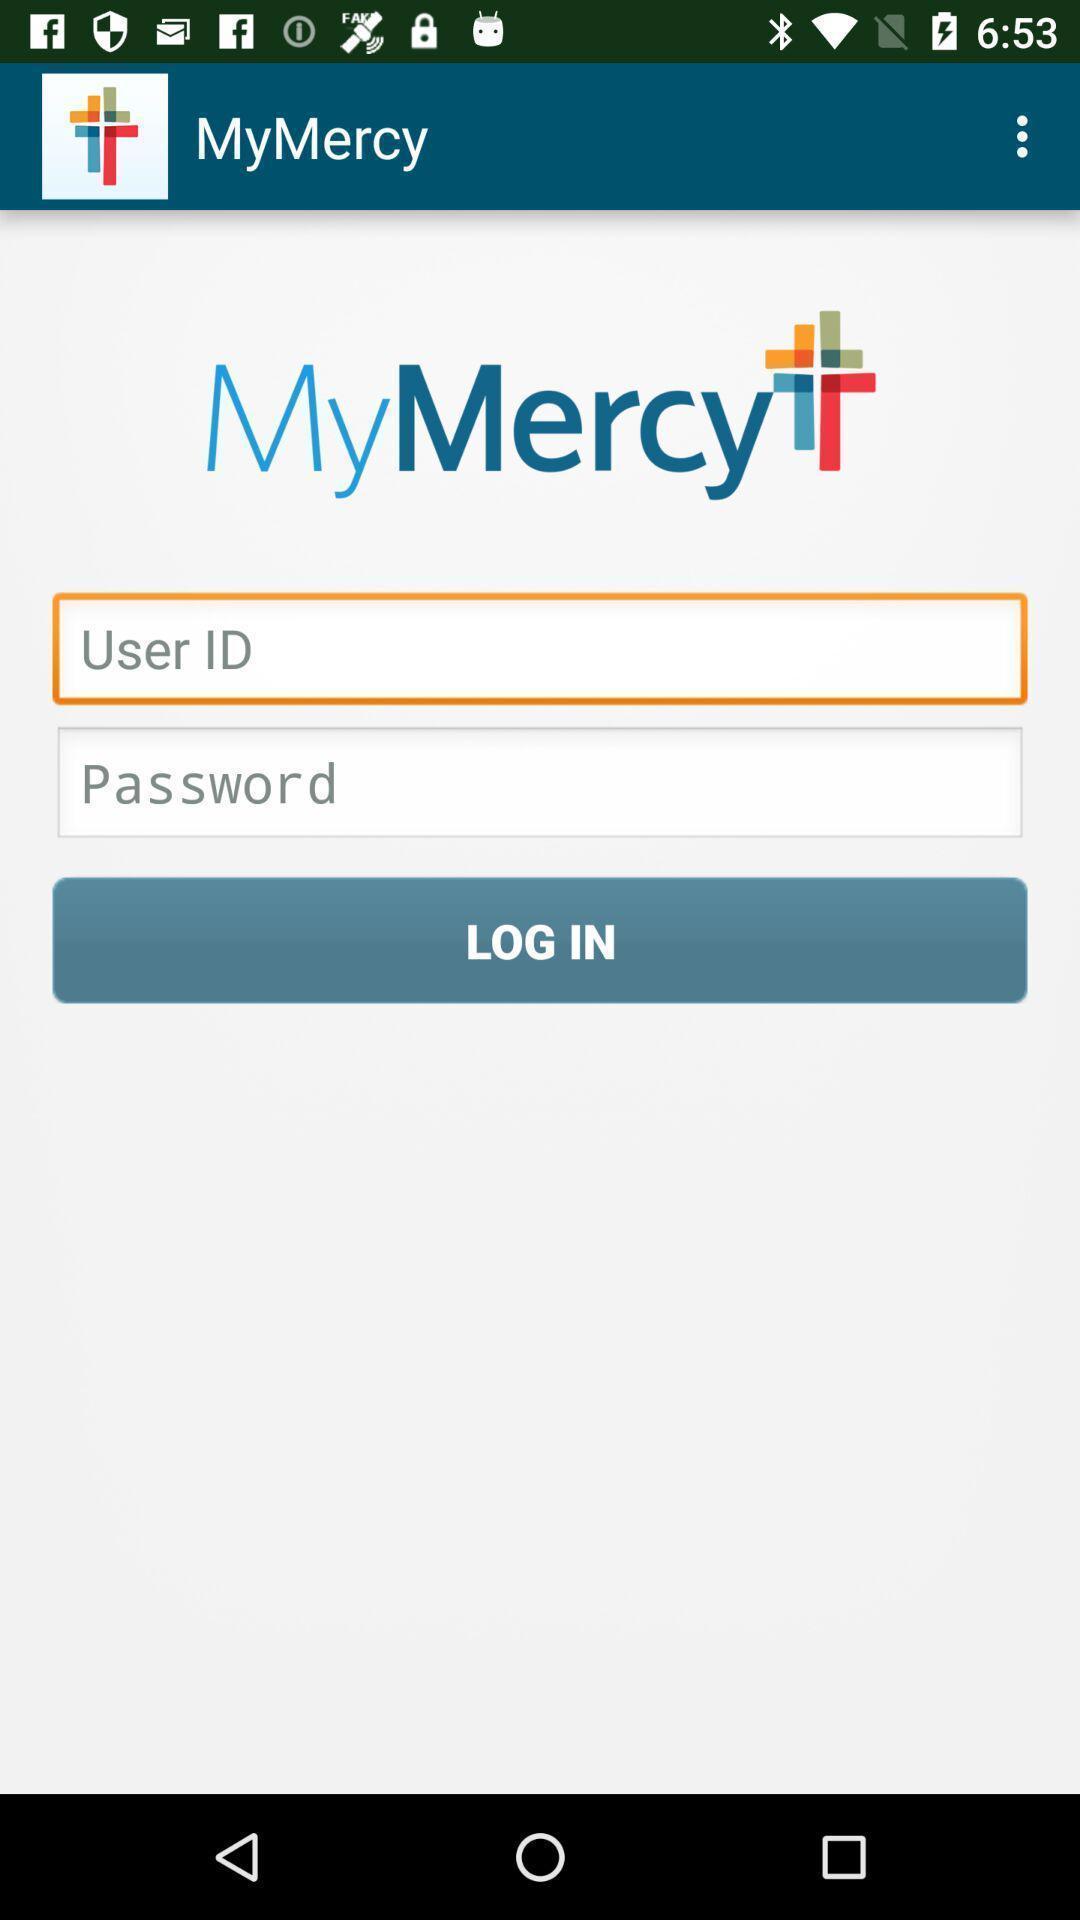What can you discern from this picture? Login page. 